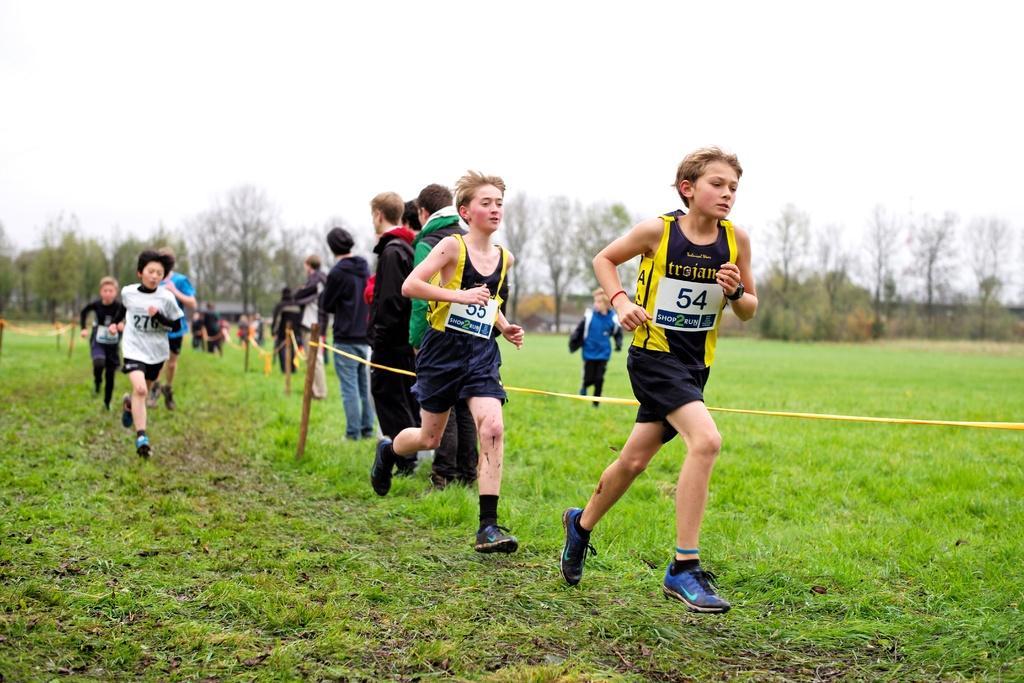Please provide a concise description of this image. In the image there are a group of children running on the grass and in the background there are trees. 